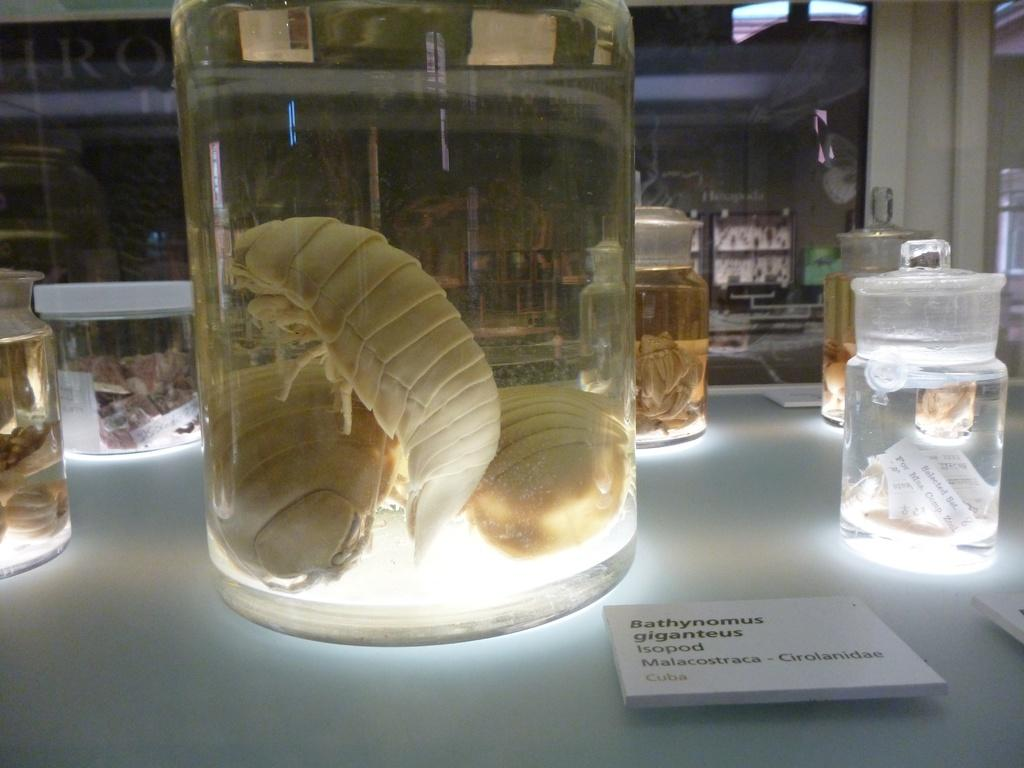What type of setting is depicted in the image? The image appears to be a lab setting. What piece of furniture is present in the image? There is a table in the image. What objects are on the table? There are jars on the table. What is inside each jar? Each jar contains some species. What type of power source is visible in the image? There is no power source visible in the image. What form does the table take in the image? The table is depicted as a flat surface with legs, but there is no specific form mentioned in the image. 